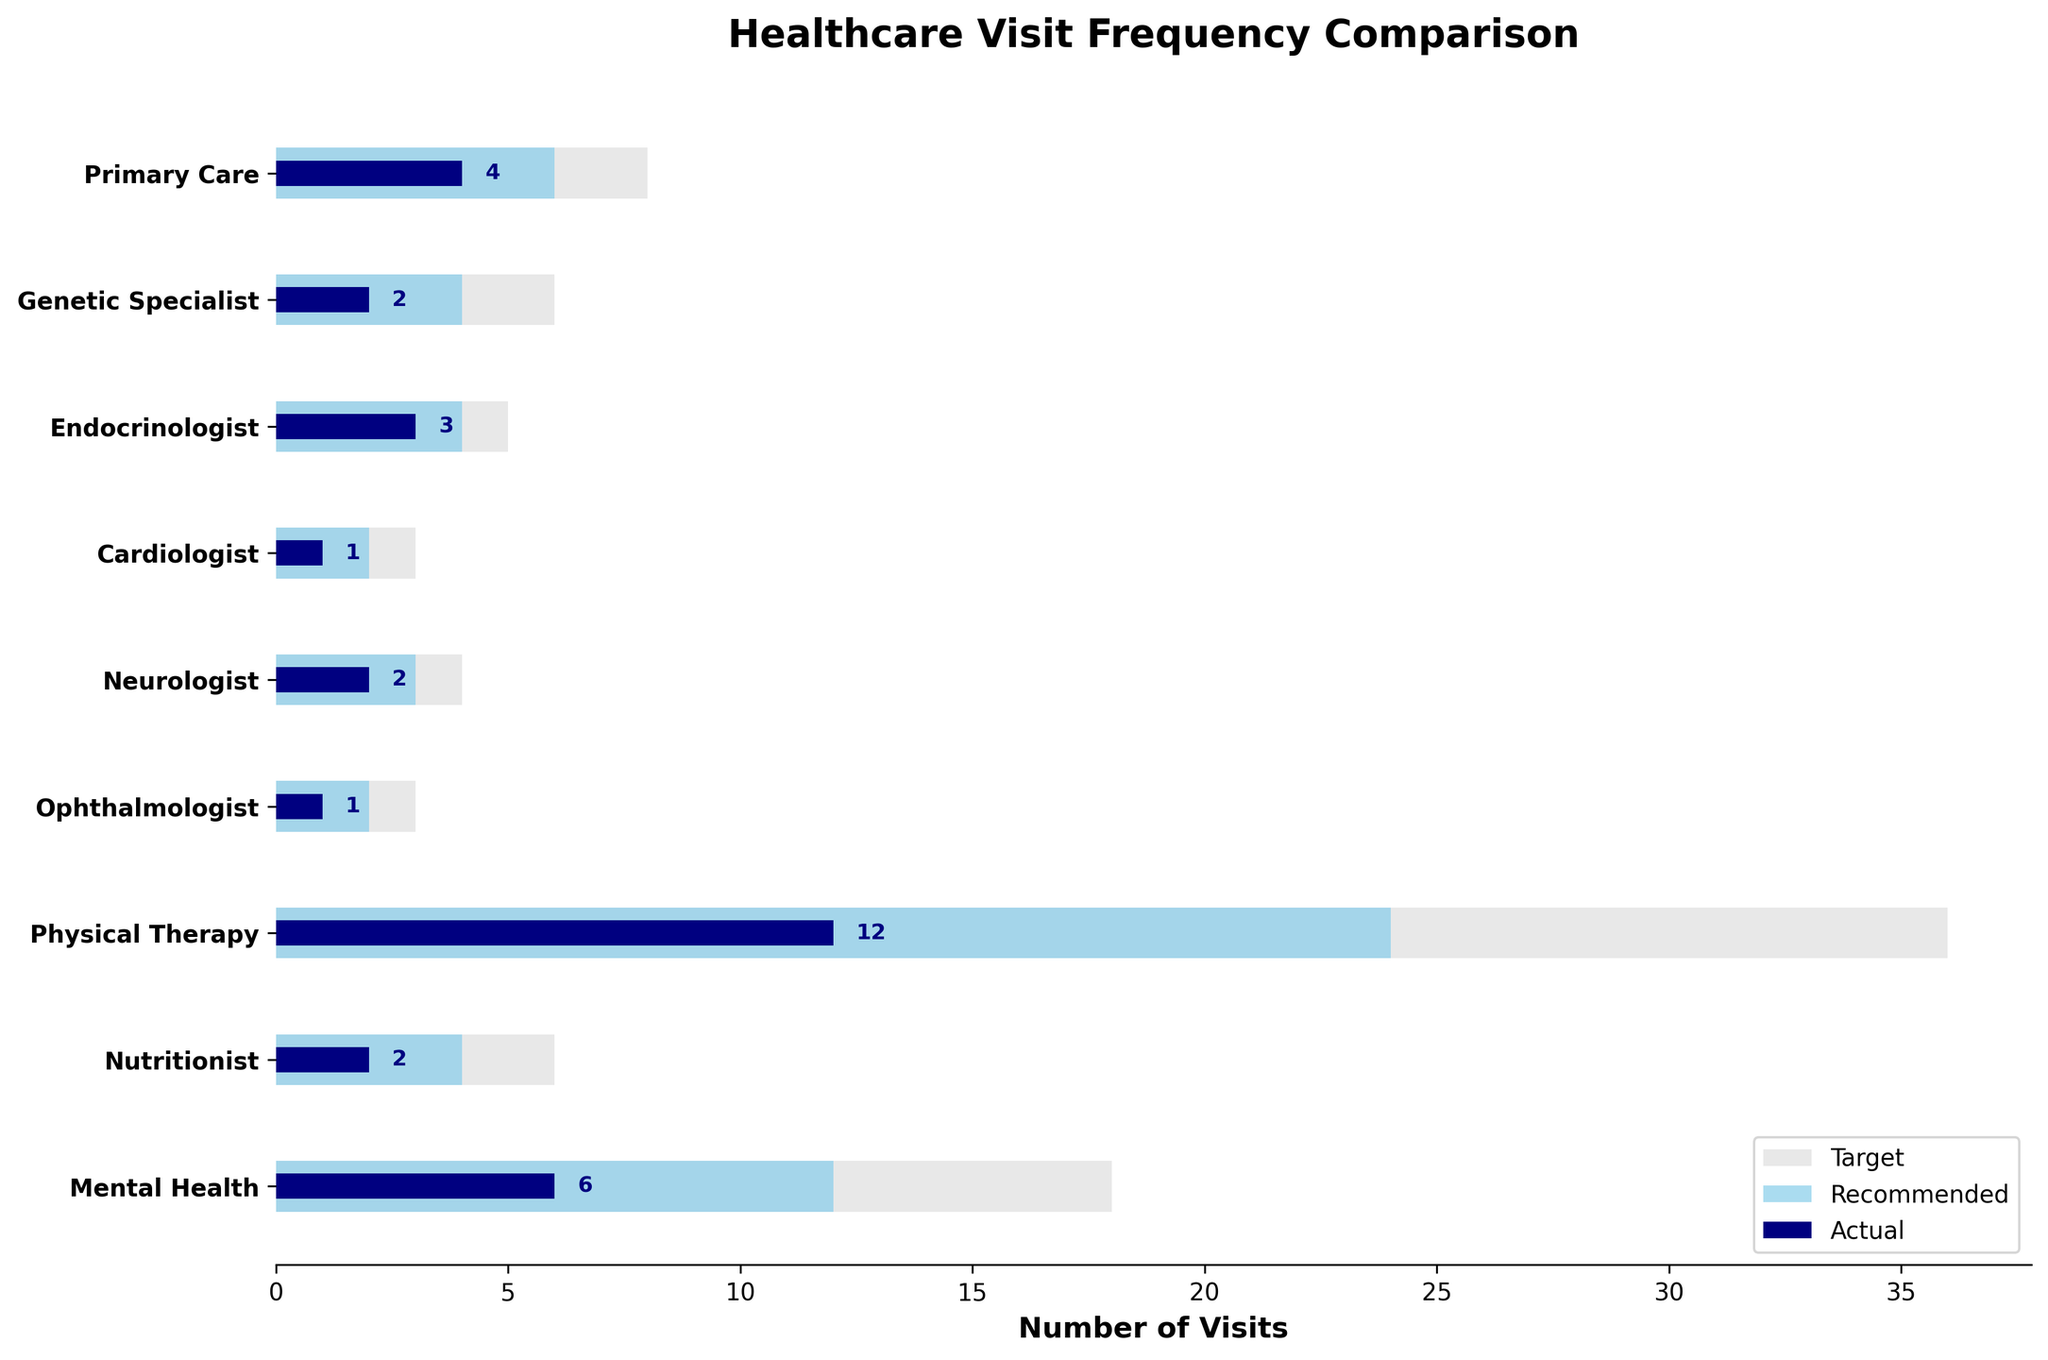What's the title of the figure? The title can be found at the top of the figure. It is directly labeled and does not require any calculations or in-depth analysis.
Answer: Healthcare Visit Frequency Comparison How many healthcare categories are shown in the figure? To determine the number of categories, simply count the number of different labels on the y-axis of the plot.
Answer: 9 Which healthcare provider category has the highest actual visit rate? Compare the actual visit rates for each category by looking at the length of the darkest bars in the figure and identify the longest one.
Answer: Physical Therapy What's the difference between the recommended and actual visit rates for the Nutritionist category? To find the difference, subtract the actual visit number (2) from the recommended visit number (4).
Answer: 2 Does any healthcare category meet its target visit rate? Assess if any of the actual visit bars overlap or are equal to the target bars.
Answer: No What's the average number of recommended visits across all categories? First, sum the recommended visits for all categories: 6 + 4 + 4 + 2 + 3 + 2 + 24 + 4 + 12 = 61. Then divide by the number of categories (9).
Answer: 6.8 Which two healthcare categories have the smallest gap between recommended and target visit rates? Calculate the difference between the recommended and target rates for each category and identify the two smallest differences.
Answer: Endocrinologist and Cardiologist Is the actual visit rate for Genetic Specialist more than 50% of its target rate? Divide the actual visits (2) by the target visits (6) and multiply by 100 to get the percentage. 2/6 = 33.33%.
Answer: No Which three categories have the largest difference between actual and recommended visit rates? Calculate the difference for each category, then compare and rank the differences to find the top three.
Answer: Physical Therapy, Mental Health, Primary Care 